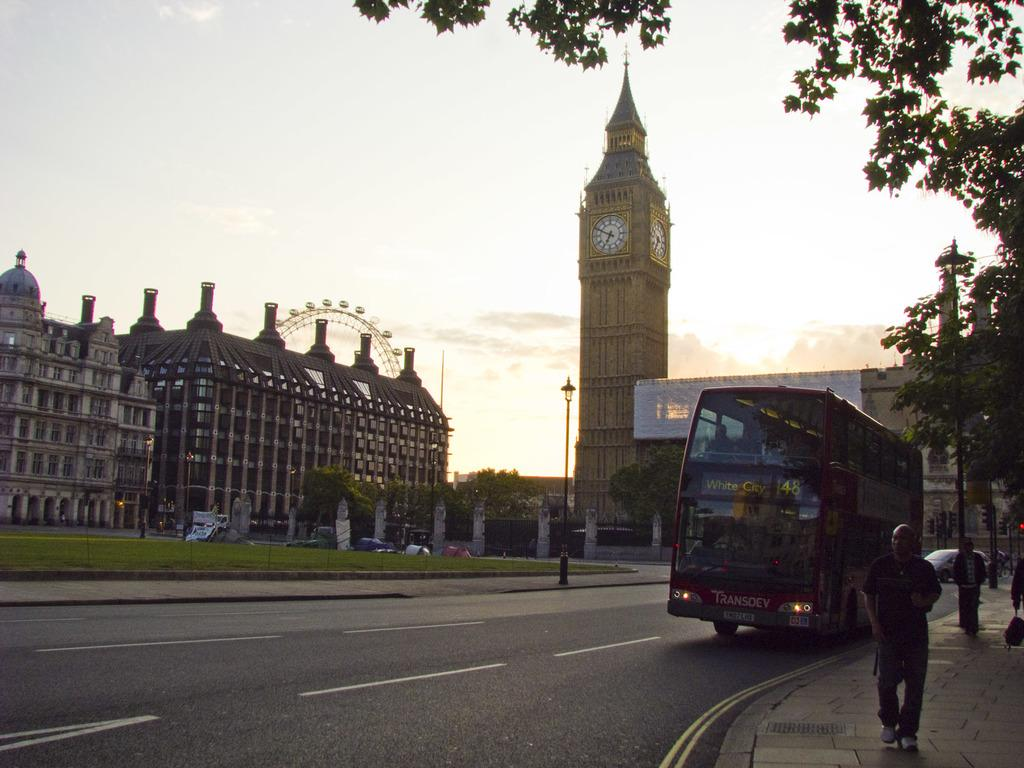Provide a one-sentence caption for the provided image. The double decker bus stopped in front of Big Ben is headed to White City. 